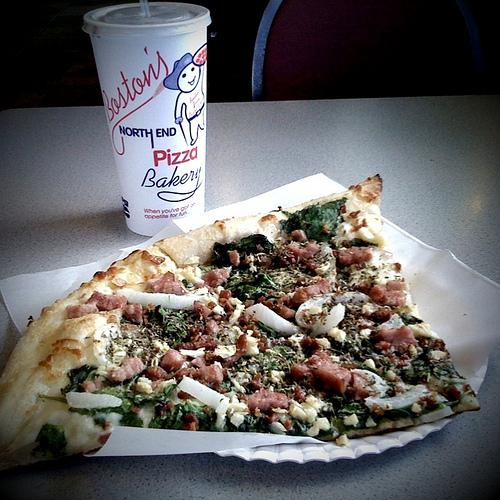Question: what kind of food is this?
Choices:
A. Pizza.
B. Pasta.
C. Sandwiches.
D. Tacos.
Answer with the letter. Answer: A Question: how many slices are there?
Choices:
A. Zero.
B. One.
C. Two.
D. Three.
Answer with the letter. Answer: C Question: what town was this photo taken in?
Choices:
A. Chicago.
B. L.a.
C. Olympia.
D. Boston.
Answer with the letter. Answer: D Question: where is the pizza sitting?
Choices:
A. On table.
B. On the counter.
C. In the fridge.
D. On the stove.
Answer with the letter. Answer: A Question: how many colors are on the cup?
Choices:
A. One.
B. Three.
C. Four.
D. Two.
Answer with the letter. Answer: C 